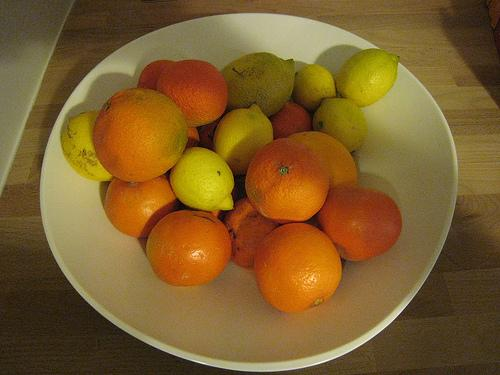Estimate how many oranges and lemons can be seen in the bowl. There are twelve oranges and seven lemons in the bowl. What type of fruits can you find in this image? There are oranges and lemons on the plate. Briefly describe the primary components of this image. The image features a white plate containing oranges and lemons, placed on a wooden table with a white wall next to it. Explain the presentation of the plate and its contents. A white, round ceramic plate holds a pile of oranges and lemons, with a few lemons on the right side and oranges on top of each other. Identify some possible distinguishing characteristics of the fruits in this image. A lemon has a green pointy tip, while an orange has a brown stem. Characterize the setting in which the bowl of fruit is placed. The bowl is placed on a light stained wooden table, near a white surface and against a white wall. Can you see shadows in the image? If so, where? There are shadows cast by the oranges, the rounded edge of the plate, and on the wood floor. What is the relative size of the lemons compared to the oranges? The lemons are smaller than the oranges. What is the overall sentiment or emotion portrayed by this image? The image has a neutral, inviting sentiment, showcasing a bowl of fresh fruits. Do any of the fruits appear to have imperfections? If so, describe them. An orange has a green spot, and a lemon shows brown spots on its rind, indicating a possible rot. Pinpoint the location of the orange with a green spot. X:152 Y:96 Width:35 Height:35 Describe the image in a sentence. There is a pile of oranges and lemons on a white ceramic plate on a wooden table. Rate the image quality from 1 to 10, where 1 is the lowest and 10 is the highest. 8, as the image is clear and well-composed but has some imperfections. What type of surface is next to the white wall? A white surface is next to the white wall. Locate the shadow created by the edge of the white ceramic plate. X:31 Y:5 Width:263 Height:263 What is the sentiment evoked by this image? The image feels refreshing and natural. Which fruit has a green pointy tip in the image? A lemon has a green pointy tip. What is the shape of the plate? The plate is round and white. Which fruit is under the other fruit? A lemon is under an orange. Identify all fruit with spots. One lemon has brown spots and one orange has a green spot. What is the difference between the size of lemons and oranges? Lemons are smaller than oranges. Is there any anomaly in the fruit's appearance? Yes, there are brown spots on one lemon and a green spot on one orange. What type of floor is the white bowl on? The white bowl is on a wood floor. How many oranges are in the bowl? Twelve oranges are in the bowl. What objects are interacting in this image? Oranges, lemons, a white ceramic plate, and a wooden table. Highlight the areas where the oranges and lemons are placed. Oranges: X:110 Y:57 Width:260 Height:260, Lemons: X:177 Y:30 Width:231 Height:231 Identify the total count of lemons present in the image. There are seven lemons in the image. Describe the table's appearance. The table is light stained wooden with some shadow. Examine the spots on the lemon rind. There are brown spots on the lemon rind at X:59 Y:110 Width:55 Height:55. Are there any text present in the image? No, there is no text present in the image. 